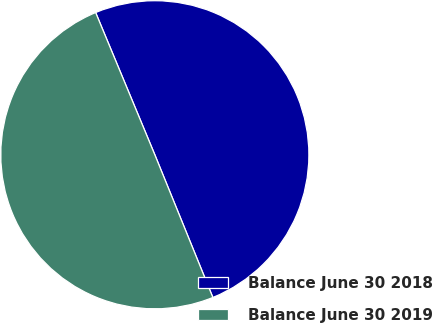Convert chart. <chart><loc_0><loc_0><loc_500><loc_500><pie_chart><fcel>Balance June 30 2018<fcel>Balance June 30 2019<nl><fcel>50.13%<fcel>49.87%<nl></chart> 